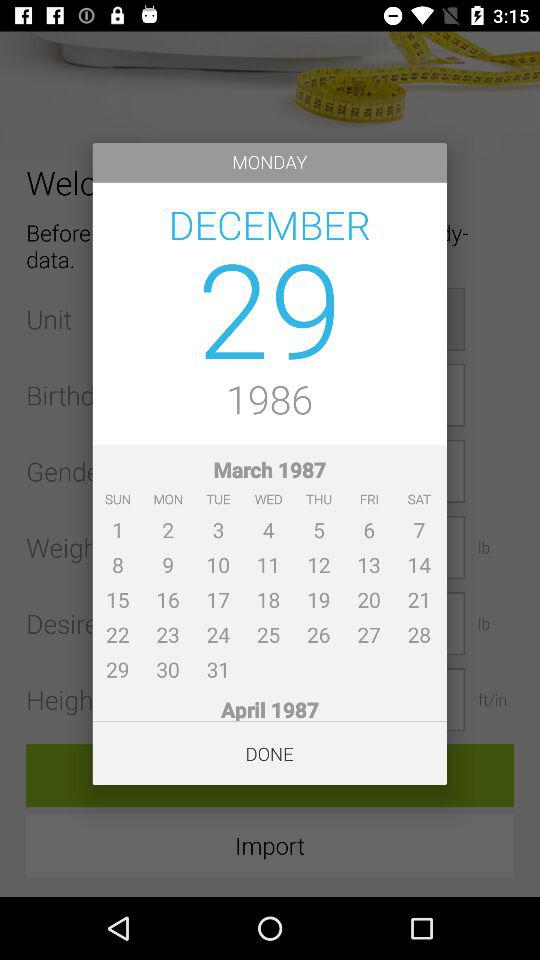Which date is selected? The selected date is Monday, December 29, 1986. 